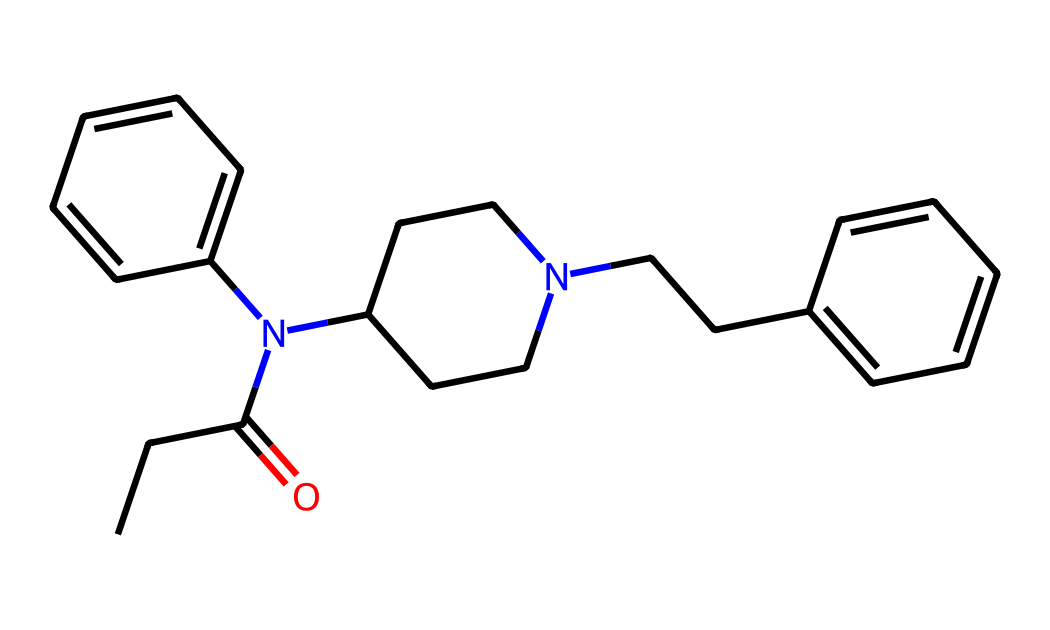What is the primary functional group present in this chemical? The chemical structure contains a carbonyl group (C=O) indicated by the "=O" in the structure. Functional groups such as amines and phenols are also present, but the carbonyl is prominently featured.
Answer: carbonyl How many nitrogen atoms are present in this molecule? By examining the structure, we can identify two distinct nitrogen atoms in the amine groups (as indicated by the "N" symbols). Therefore, the total count of nitrogen atoms is two.
Answer: two What type of organic compound is this chemical? This compound is an opioid analgesic, categorized under both synthetic opioids and potentially classified as a solid depending on its physical state at room temperature. It is characterized by its ability to bind to opioid receptors.
Answer: opioid analgesic How many aromatic rings are in the chemical structure? The structure contains two benzene rings, discernible by the cyclic arrangement of carbon atoms (indicated by "ccccc"). Each ring contributes to the overall stability and activity of the compound.
Answer: two What is the total number of carbon atoms in this chemical? Counting all carbon atoms represented in the structure, there are a total of 22 carbon atoms present. This includes those in the chains and rings within the molecule.
Answer: twenty-two What type of bond connects the carbonyl group to the amine? The carbonyl group forms a single covalent bond with the nitrogen atom of the amine, represented by "N(" in the structure. This indicates a bond type that is typical in amides.
Answer: single covalent bond 